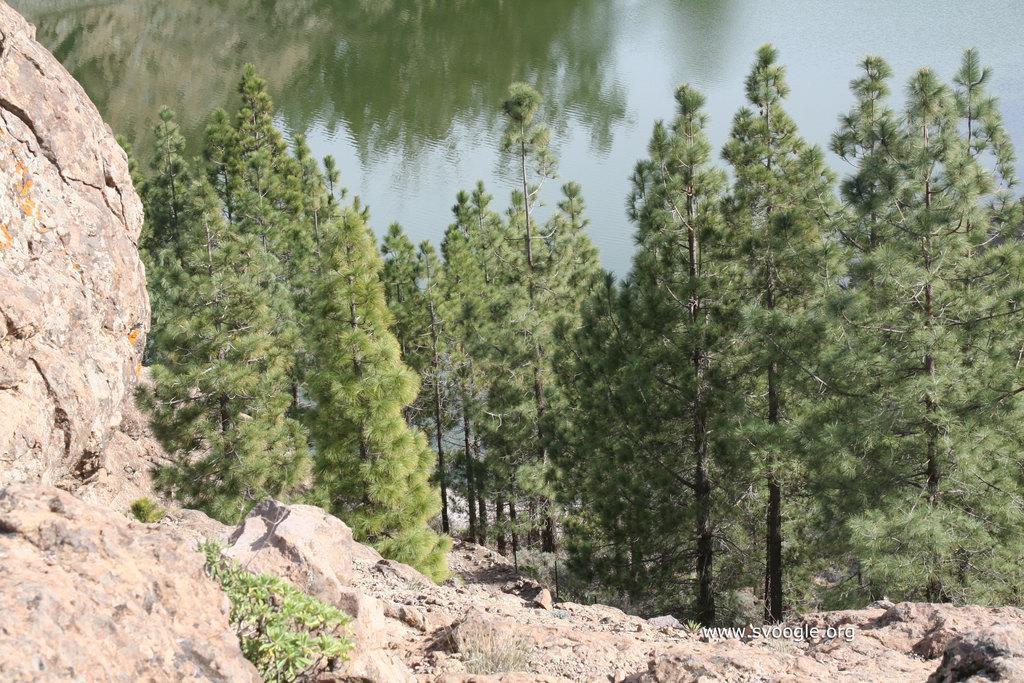Could you give a brief overview of what you see in this image? In this image there are rocks, trees, water and there is a watermark on the image. 